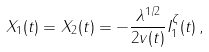<formula> <loc_0><loc_0><loc_500><loc_500>X _ { 1 } ( t ) = X _ { 2 } ( t ) = - \frac { \lambda ^ { 1 / 2 } } { 2 v ( t ) } I _ { 1 } ^ { \zeta } ( t ) \, ,</formula> 